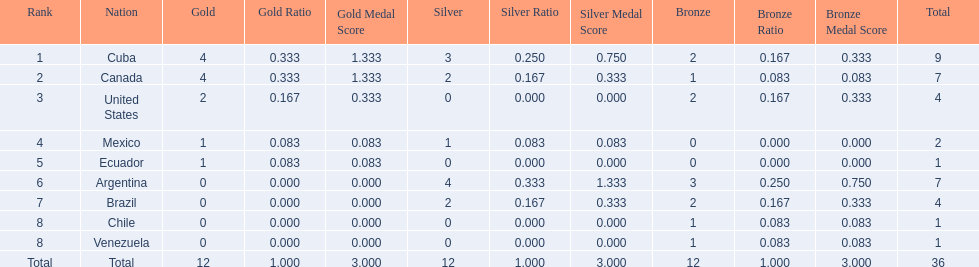What were the amounts of bronze medals won by the countries? 2, 1, 2, 0, 0, 3, 2, 1, 1. Which is the highest? 3. Which nation had this amount? Argentina. 